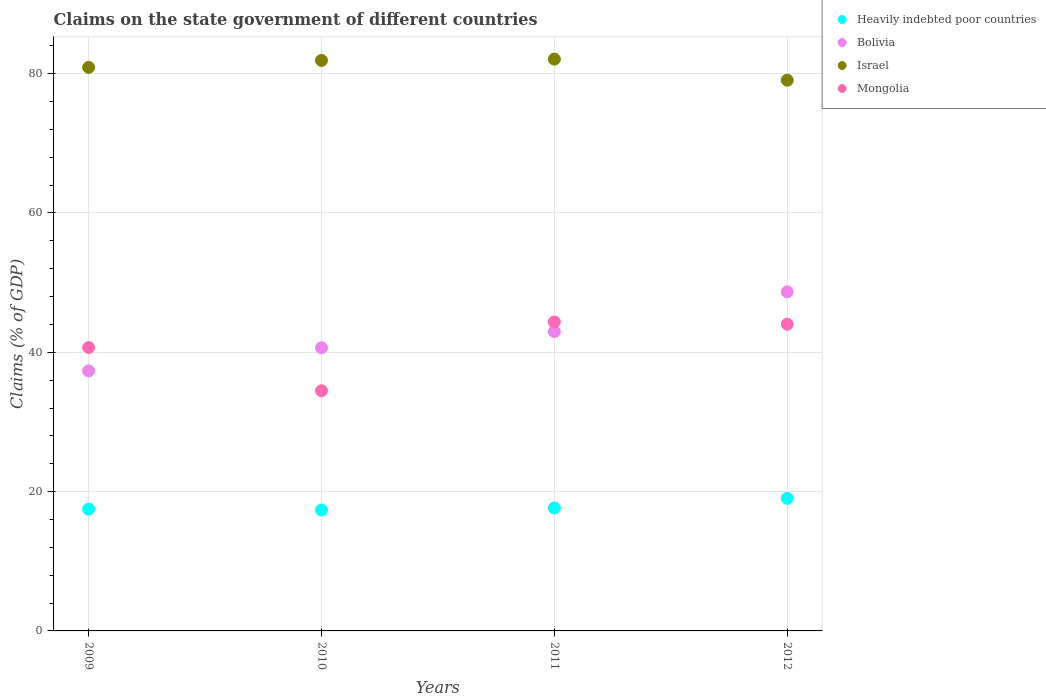Is the number of dotlines equal to the number of legend labels?
Provide a short and direct response. Yes. What is the percentage of GDP claimed on the state government in Mongolia in 2009?
Provide a short and direct response. 40.68. Across all years, what is the maximum percentage of GDP claimed on the state government in Israel?
Give a very brief answer. 82.08. Across all years, what is the minimum percentage of GDP claimed on the state government in Heavily indebted poor countries?
Keep it short and to the point. 17.36. In which year was the percentage of GDP claimed on the state government in Mongolia maximum?
Your answer should be very brief. 2011. In which year was the percentage of GDP claimed on the state government in Bolivia minimum?
Ensure brevity in your answer.  2009. What is the total percentage of GDP claimed on the state government in Heavily indebted poor countries in the graph?
Ensure brevity in your answer.  71.51. What is the difference between the percentage of GDP claimed on the state government in Mongolia in 2010 and that in 2012?
Ensure brevity in your answer.  -9.55. What is the difference between the percentage of GDP claimed on the state government in Heavily indebted poor countries in 2009 and the percentage of GDP claimed on the state government in Bolivia in 2010?
Your answer should be very brief. -23.18. What is the average percentage of GDP claimed on the state government in Mongolia per year?
Offer a terse response. 40.89. In the year 2012, what is the difference between the percentage of GDP claimed on the state government in Bolivia and percentage of GDP claimed on the state government in Mongolia?
Provide a short and direct response. 4.65. What is the ratio of the percentage of GDP claimed on the state government in Israel in 2009 to that in 2012?
Provide a succinct answer. 1.02. Is the percentage of GDP claimed on the state government in Mongolia in 2009 less than that in 2010?
Provide a short and direct response. No. What is the difference between the highest and the second highest percentage of GDP claimed on the state government in Heavily indebted poor countries?
Your response must be concise. 1.38. What is the difference between the highest and the lowest percentage of GDP claimed on the state government in Heavily indebted poor countries?
Your answer should be compact. 1.67. Is the sum of the percentage of GDP claimed on the state government in Mongolia in 2010 and 2011 greater than the maximum percentage of GDP claimed on the state government in Israel across all years?
Keep it short and to the point. No. Is it the case that in every year, the sum of the percentage of GDP claimed on the state government in Heavily indebted poor countries and percentage of GDP claimed on the state government in Mongolia  is greater than the sum of percentage of GDP claimed on the state government in Bolivia and percentage of GDP claimed on the state government in Israel?
Offer a very short reply. No. Is it the case that in every year, the sum of the percentage of GDP claimed on the state government in Mongolia and percentage of GDP claimed on the state government in Bolivia  is greater than the percentage of GDP claimed on the state government in Israel?
Your answer should be very brief. No. Does the percentage of GDP claimed on the state government in Heavily indebted poor countries monotonically increase over the years?
Make the answer very short. No. Is the percentage of GDP claimed on the state government in Israel strictly greater than the percentage of GDP claimed on the state government in Bolivia over the years?
Your answer should be very brief. Yes. Is the percentage of GDP claimed on the state government in Heavily indebted poor countries strictly less than the percentage of GDP claimed on the state government in Bolivia over the years?
Your answer should be compact. Yes. How many dotlines are there?
Provide a short and direct response. 4. Are the values on the major ticks of Y-axis written in scientific E-notation?
Your response must be concise. No. Does the graph contain any zero values?
Ensure brevity in your answer.  No. Does the graph contain grids?
Provide a succinct answer. Yes. How many legend labels are there?
Provide a succinct answer. 4. How are the legend labels stacked?
Offer a very short reply. Vertical. What is the title of the graph?
Your answer should be compact. Claims on the state government of different countries. What is the label or title of the Y-axis?
Offer a terse response. Claims (% of GDP). What is the Claims (% of GDP) in Heavily indebted poor countries in 2009?
Give a very brief answer. 17.47. What is the Claims (% of GDP) in Bolivia in 2009?
Give a very brief answer. 37.32. What is the Claims (% of GDP) in Israel in 2009?
Offer a terse response. 80.9. What is the Claims (% of GDP) of Mongolia in 2009?
Provide a succinct answer. 40.68. What is the Claims (% of GDP) of Heavily indebted poor countries in 2010?
Offer a terse response. 17.36. What is the Claims (% of GDP) in Bolivia in 2010?
Offer a terse response. 40.65. What is the Claims (% of GDP) of Israel in 2010?
Your answer should be compact. 81.89. What is the Claims (% of GDP) in Mongolia in 2010?
Your answer should be compact. 34.48. What is the Claims (% of GDP) of Heavily indebted poor countries in 2011?
Ensure brevity in your answer.  17.65. What is the Claims (% of GDP) in Bolivia in 2011?
Provide a succinct answer. 42.97. What is the Claims (% of GDP) in Israel in 2011?
Give a very brief answer. 82.08. What is the Claims (% of GDP) of Mongolia in 2011?
Offer a terse response. 44.36. What is the Claims (% of GDP) of Heavily indebted poor countries in 2012?
Offer a terse response. 19.03. What is the Claims (% of GDP) in Bolivia in 2012?
Offer a very short reply. 48.68. What is the Claims (% of GDP) in Israel in 2012?
Your answer should be compact. 79.06. What is the Claims (% of GDP) of Mongolia in 2012?
Keep it short and to the point. 44.03. Across all years, what is the maximum Claims (% of GDP) in Heavily indebted poor countries?
Keep it short and to the point. 19.03. Across all years, what is the maximum Claims (% of GDP) of Bolivia?
Your response must be concise. 48.68. Across all years, what is the maximum Claims (% of GDP) of Israel?
Your response must be concise. 82.08. Across all years, what is the maximum Claims (% of GDP) in Mongolia?
Provide a succinct answer. 44.36. Across all years, what is the minimum Claims (% of GDP) of Heavily indebted poor countries?
Make the answer very short. 17.36. Across all years, what is the minimum Claims (% of GDP) of Bolivia?
Make the answer very short. 37.32. Across all years, what is the minimum Claims (% of GDP) in Israel?
Provide a succinct answer. 79.06. Across all years, what is the minimum Claims (% of GDP) of Mongolia?
Offer a terse response. 34.48. What is the total Claims (% of GDP) of Heavily indebted poor countries in the graph?
Your answer should be very brief. 71.51. What is the total Claims (% of GDP) of Bolivia in the graph?
Ensure brevity in your answer.  169.63. What is the total Claims (% of GDP) in Israel in the graph?
Provide a succinct answer. 323.94. What is the total Claims (% of GDP) of Mongolia in the graph?
Keep it short and to the point. 163.54. What is the difference between the Claims (% of GDP) in Heavily indebted poor countries in 2009 and that in 2010?
Provide a succinct answer. 0.12. What is the difference between the Claims (% of GDP) of Bolivia in 2009 and that in 2010?
Give a very brief answer. -3.33. What is the difference between the Claims (% of GDP) in Israel in 2009 and that in 2010?
Provide a short and direct response. -1. What is the difference between the Claims (% of GDP) in Mongolia in 2009 and that in 2010?
Make the answer very short. 6.2. What is the difference between the Claims (% of GDP) of Heavily indebted poor countries in 2009 and that in 2011?
Make the answer very short. -0.18. What is the difference between the Claims (% of GDP) of Bolivia in 2009 and that in 2011?
Your answer should be very brief. -5.65. What is the difference between the Claims (% of GDP) of Israel in 2009 and that in 2011?
Make the answer very short. -1.19. What is the difference between the Claims (% of GDP) in Mongolia in 2009 and that in 2011?
Ensure brevity in your answer.  -3.68. What is the difference between the Claims (% of GDP) in Heavily indebted poor countries in 2009 and that in 2012?
Ensure brevity in your answer.  -1.55. What is the difference between the Claims (% of GDP) in Bolivia in 2009 and that in 2012?
Your response must be concise. -11.35. What is the difference between the Claims (% of GDP) in Israel in 2009 and that in 2012?
Give a very brief answer. 1.84. What is the difference between the Claims (% of GDP) of Mongolia in 2009 and that in 2012?
Offer a terse response. -3.35. What is the difference between the Claims (% of GDP) in Heavily indebted poor countries in 2010 and that in 2011?
Your response must be concise. -0.29. What is the difference between the Claims (% of GDP) in Bolivia in 2010 and that in 2011?
Make the answer very short. -2.32. What is the difference between the Claims (% of GDP) of Israel in 2010 and that in 2011?
Provide a succinct answer. -0.19. What is the difference between the Claims (% of GDP) of Mongolia in 2010 and that in 2011?
Offer a terse response. -9.88. What is the difference between the Claims (% of GDP) in Heavily indebted poor countries in 2010 and that in 2012?
Provide a short and direct response. -1.67. What is the difference between the Claims (% of GDP) in Bolivia in 2010 and that in 2012?
Your answer should be very brief. -8.02. What is the difference between the Claims (% of GDP) in Israel in 2010 and that in 2012?
Offer a very short reply. 2.83. What is the difference between the Claims (% of GDP) in Mongolia in 2010 and that in 2012?
Offer a very short reply. -9.55. What is the difference between the Claims (% of GDP) in Heavily indebted poor countries in 2011 and that in 2012?
Make the answer very short. -1.38. What is the difference between the Claims (% of GDP) in Bolivia in 2011 and that in 2012?
Give a very brief answer. -5.7. What is the difference between the Claims (% of GDP) in Israel in 2011 and that in 2012?
Your answer should be very brief. 3.02. What is the difference between the Claims (% of GDP) in Mongolia in 2011 and that in 2012?
Give a very brief answer. 0.33. What is the difference between the Claims (% of GDP) of Heavily indebted poor countries in 2009 and the Claims (% of GDP) of Bolivia in 2010?
Offer a terse response. -23.18. What is the difference between the Claims (% of GDP) in Heavily indebted poor countries in 2009 and the Claims (% of GDP) in Israel in 2010?
Your answer should be compact. -64.42. What is the difference between the Claims (% of GDP) in Heavily indebted poor countries in 2009 and the Claims (% of GDP) in Mongolia in 2010?
Offer a terse response. -17.01. What is the difference between the Claims (% of GDP) of Bolivia in 2009 and the Claims (% of GDP) of Israel in 2010?
Your answer should be very brief. -44.57. What is the difference between the Claims (% of GDP) of Bolivia in 2009 and the Claims (% of GDP) of Mongolia in 2010?
Give a very brief answer. 2.85. What is the difference between the Claims (% of GDP) of Israel in 2009 and the Claims (% of GDP) of Mongolia in 2010?
Your answer should be compact. 46.42. What is the difference between the Claims (% of GDP) in Heavily indebted poor countries in 2009 and the Claims (% of GDP) in Bolivia in 2011?
Ensure brevity in your answer.  -25.5. What is the difference between the Claims (% of GDP) of Heavily indebted poor countries in 2009 and the Claims (% of GDP) of Israel in 2011?
Ensure brevity in your answer.  -64.61. What is the difference between the Claims (% of GDP) of Heavily indebted poor countries in 2009 and the Claims (% of GDP) of Mongolia in 2011?
Provide a short and direct response. -26.89. What is the difference between the Claims (% of GDP) of Bolivia in 2009 and the Claims (% of GDP) of Israel in 2011?
Your answer should be very brief. -44.76. What is the difference between the Claims (% of GDP) of Bolivia in 2009 and the Claims (% of GDP) of Mongolia in 2011?
Your answer should be compact. -7.03. What is the difference between the Claims (% of GDP) of Israel in 2009 and the Claims (% of GDP) of Mongolia in 2011?
Your answer should be compact. 36.54. What is the difference between the Claims (% of GDP) of Heavily indebted poor countries in 2009 and the Claims (% of GDP) of Bolivia in 2012?
Offer a very short reply. -31.2. What is the difference between the Claims (% of GDP) of Heavily indebted poor countries in 2009 and the Claims (% of GDP) of Israel in 2012?
Your response must be concise. -61.59. What is the difference between the Claims (% of GDP) in Heavily indebted poor countries in 2009 and the Claims (% of GDP) in Mongolia in 2012?
Give a very brief answer. -26.56. What is the difference between the Claims (% of GDP) in Bolivia in 2009 and the Claims (% of GDP) in Israel in 2012?
Offer a very short reply. -41.74. What is the difference between the Claims (% of GDP) of Bolivia in 2009 and the Claims (% of GDP) of Mongolia in 2012?
Provide a short and direct response. -6.7. What is the difference between the Claims (% of GDP) of Israel in 2009 and the Claims (% of GDP) of Mongolia in 2012?
Your response must be concise. 36.87. What is the difference between the Claims (% of GDP) in Heavily indebted poor countries in 2010 and the Claims (% of GDP) in Bolivia in 2011?
Provide a short and direct response. -25.62. What is the difference between the Claims (% of GDP) of Heavily indebted poor countries in 2010 and the Claims (% of GDP) of Israel in 2011?
Keep it short and to the point. -64.73. What is the difference between the Claims (% of GDP) in Heavily indebted poor countries in 2010 and the Claims (% of GDP) in Mongolia in 2011?
Offer a terse response. -27. What is the difference between the Claims (% of GDP) of Bolivia in 2010 and the Claims (% of GDP) of Israel in 2011?
Keep it short and to the point. -41.43. What is the difference between the Claims (% of GDP) of Bolivia in 2010 and the Claims (% of GDP) of Mongolia in 2011?
Your answer should be very brief. -3.7. What is the difference between the Claims (% of GDP) in Israel in 2010 and the Claims (% of GDP) in Mongolia in 2011?
Offer a terse response. 37.54. What is the difference between the Claims (% of GDP) in Heavily indebted poor countries in 2010 and the Claims (% of GDP) in Bolivia in 2012?
Provide a short and direct response. -31.32. What is the difference between the Claims (% of GDP) of Heavily indebted poor countries in 2010 and the Claims (% of GDP) of Israel in 2012?
Make the answer very short. -61.7. What is the difference between the Claims (% of GDP) in Heavily indebted poor countries in 2010 and the Claims (% of GDP) in Mongolia in 2012?
Your response must be concise. -26.67. What is the difference between the Claims (% of GDP) of Bolivia in 2010 and the Claims (% of GDP) of Israel in 2012?
Your answer should be compact. -38.41. What is the difference between the Claims (% of GDP) of Bolivia in 2010 and the Claims (% of GDP) of Mongolia in 2012?
Give a very brief answer. -3.37. What is the difference between the Claims (% of GDP) in Israel in 2010 and the Claims (% of GDP) in Mongolia in 2012?
Your response must be concise. 37.87. What is the difference between the Claims (% of GDP) of Heavily indebted poor countries in 2011 and the Claims (% of GDP) of Bolivia in 2012?
Your answer should be compact. -31.03. What is the difference between the Claims (% of GDP) in Heavily indebted poor countries in 2011 and the Claims (% of GDP) in Israel in 2012?
Provide a short and direct response. -61.41. What is the difference between the Claims (% of GDP) of Heavily indebted poor countries in 2011 and the Claims (% of GDP) of Mongolia in 2012?
Keep it short and to the point. -26.38. What is the difference between the Claims (% of GDP) in Bolivia in 2011 and the Claims (% of GDP) in Israel in 2012?
Give a very brief answer. -36.09. What is the difference between the Claims (% of GDP) of Bolivia in 2011 and the Claims (% of GDP) of Mongolia in 2012?
Make the answer very short. -1.05. What is the difference between the Claims (% of GDP) in Israel in 2011 and the Claims (% of GDP) in Mongolia in 2012?
Give a very brief answer. 38.06. What is the average Claims (% of GDP) of Heavily indebted poor countries per year?
Keep it short and to the point. 17.88. What is the average Claims (% of GDP) of Bolivia per year?
Offer a very short reply. 42.41. What is the average Claims (% of GDP) in Israel per year?
Make the answer very short. 80.98. What is the average Claims (% of GDP) in Mongolia per year?
Provide a succinct answer. 40.89. In the year 2009, what is the difference between the Claims (% of GDP) in Heavily indebted poor countries and Claims (% of GDP) in Bolivia?
Your answer should be compact. -19.85. In the year 2009, what is the difference between the Claims (% of GDP) of Heavily indebted poor countries and Claims (% of GDP) of Israel?
Your answer should be very brief. -63.42. In the year 2009, what is the difference between the Claims (% of GDP) of Heavily indebted poor countries and Claims (% of GDP) of Mongolia?
Keep it short and to the point. -23.21. In the year 2009, what is the difference between the Claims (% of GDP) in Bolivia and Claims (% of GDP) in Israel?
Your response must be concise. -43.57. In the year 2009, what is the difference between the Claims (% of GDP) in Bolivia and Claims (% of GDP) in Mongolia?
Offer a terse response. -3.36. In the year 2009, what is the difference between the Claims (% of GDP) in Israel and Claims (% of GDP) in Mongolia?
Give a very brief answer. 40.22. In the year 2010, what is the difference between the Claims (% of GDP) of Heavily indebted poor countries and Claims (% of GDP) of Bolivia?
Offer a very short reply. -23.3. In the year 2010, what is the difference between the Claims (% of GDP) in Heavily indebted poor countries and Claims (% of GDP) in Israel?
Offer a very short reply. -64.54. In the year 2010, what is the difference between the Claims (% of GDP) of Heavily indebted poor countries and Claims (% of GDP) of Mongolia?
Keep it short and to the point. -17.12. In the year 2010, what is the difference between the Claims (% of GDP) of Bolivia and Claims (% of GDP) of Israel?
Offer a terse response. -41.24. In the year 2010, what is the difference between the Claims (% of GDP) in Bolivia and Claims (% of GDP) in Mongolia?
Provide a short and direct response. 6.18. In the year 2010, what is the difference between the Claims (% of GDP) of Israel and Claims (% of GDP) of Mongolia?
Your answer should be compact. 47.42. In the year 2011, what is the difference between the Claims (% of GDP) of Heavily indebted poor countries and Claims (% of GDP) of Bolivia?
Make the answer very short. -25.32. In the year 2011, what is the difference between the Claims (% of GDP) in Heavily indebted poor countries and Claims (% of GDP) in Israel?
Your answer should be compact. -64.43. In the year 2011, what is the difference between the Claims (% of GDP) of Heavily indebted poor countries and Claims (% of GDP) of Mongolia?
Your answer should be compact. -26.71. In the year 2011, what is the difference between the Claims (% of GDP) in Bolivia and Claims (% of GDP) in Israel?
Offer a very short reply. -39.11. In the year 2011, what is the difference between the Claims (% of GDP) in Bolivia and Claims (% of GDP) in Mongolia?
Your answer should be very brief. -1.38. In the year 2011, what is the difference between the Claims (% of GDP) of Israel and Claims (% of GDP) of Mongolia?
Provide a succinct answer. 37.73. In the year 2012, what is the difference between the Claims (% of GDP) of Heavily indebted poor countries and Claims (% of GDP) of Bolivia?
Your response must be concise. -29.65. In the year 2012, what is the difference between the Claims (% of GDP) of Heavily indebted poor countries and Claims (% of GDP) of Israel?
Your response must be concise. -60.03. In the year 2012, what is the difference between the Claims (% of GDP) of Heavily indebted poor countries and Claims (% of GDP) of Mongolia?
Your response must be concise. -25. In the year 2012, what is the difference between the Claims (% of GDP) of Bolivia and Claims (% of GDP) of Israel?
Provide a short and direct response. -30.38. In the year 2012, what is the difference between the Claims (% of GDP) of Bolivia and Claims (% of GDP) of Mongolia?
Your answer should be very brief. 4.65. In the year 2012, what is the difference between the Claims (% of GDP) of Israel and Claims (% of GDP) of Mongolia?
Keep it short and to the point. 35.03. What is the ratio of the Claims (% of GDP) in Heavily indebted poor countries in 2009 to that in 2010?
Your answer should be very brief. 1.01. What is the ratio of the Claims (% of GDP) of Bolivia in 2009 to that in 2010?
Keep it short and to the point. 0.92. What is the ratio of the Claims (% of GDP) of Israel in 2009 to that in 2010?
Offer a very short reply. 0.99. What is the ratio of the Claims (% of GDP) of Mongolia in 2009 to that in 2010?
Keep it short and to the point. 1.18. What is the ratio of the Claims (% of GDP) of Bolivia in 2009 to that in 2011?
Your answer should be compact. 0.87. What is the ratio of the Claims (% of GDP) of Israel in 2009 to that in 2011?
Provide a short and direct response. 0.99. What is the ratio of the Claims (% of GDP) in Mongolia in 2009 to that in 2011?
Ensure brevity in your answer.  0.92. What is the ratio of the Claims (% of GDP) of Heavily indebted poor countries in 2009 to that in 2012?
Provide a succinct answer. 0.92. What is the ratio of the Claims (% of GDP) in Bolivia in 2009 to that in 2012?
Your response must be concise. 0.77. What is the ratio of the Claims (% of GDP) in Israel in 2009 to that in 2012?
Provide a short and direct response. 1.02. What is the ratio of the Claims (% of GDP) in Mongolia in 2009 to that in 2012?
Your answer should be very brief. 0.92. What is the ratio of the Claims (% of GDP) in Heavily indebted poor countries in 2010 to that in 2011?
Your answer should be very brief. 0.98. What is the ratio of the Claims (% of GDP) in Bolivia in 2010 to that in 2011?
Provide a succinct answer. 0.95. What is the ratio of the Claims (% of GDP) in Mongolia in 2010 to that in 2011?
Give a very brief answer. 0.78. What is the ratio of the Claims (% of GDP) of Heavily indebted poor countries in 2010 to that in 2012?
Give a very brief answer. 0.91. What is the ratio of the Claims (% of GDP) in Bolivia in 2010 to that in 2012?
Keep it short and to the point. 0.84. What is the ratio of the Claims (% of GDP) in Israel in 2010 to that in 2012?
Offer a terse response. 1.04. What is the ratio of the Claims (% of GDP) of Mongolia in 2010 to that in 2012?
Ensure brevity in your answer.  0.78. What is the ratio of the Claims (% of GDP) in Heavily indebted poor countries in 2011 to that in 2012?
Keep it short and to the point. 0.93. What is the ratio of the Claims (% of GDP) in Bolivia in 2011 to that in 2012?
Give a very brief answer. 0.88. What is the ratio of the Claims (% of GDP) of Israel in 2011 to that in 2012?
Offer a very short reply. 1.04. What is the ratio of the Claims (% of GDP) of Mongolia in 2011 to that in 2012?
Give a very brief answer. 1.01. What is the difference between the highest and the second highest Claims (% of GDP) in Heavily indebted poor countries?
Give a very brief answer. 1.38. What is the difference between the highest and the second highest Claims (% of GDP) in Bolivia?
Your answer should be compact. 5.7. What is the difference between the highest and the second highest Claims (% of GDP) in Israel?
Keep it short and to the point. 0.19. What is the difference between the highest and the second highest Claims (% of GDP) in Mongolia?
Your answer should be compact. 0.33. What is the difference between the highest and the lowest Claims (% of GDP) of Heavily indebted poor countries?
Provide a succinct answer. 1.67. What is the difference between the highest and the lowest Claims (% of GDP) in Bolivia?
Make the answer very short. 11.35. What is the difference between the highest and the lowest Claims (% of GDP) in Israel?
Ensure brevity in your answer.  3.02. What is the difference between the highest and the lowest Claims (% of GDP) of Mongolia?
Provide a succinct answer. 9.88. 